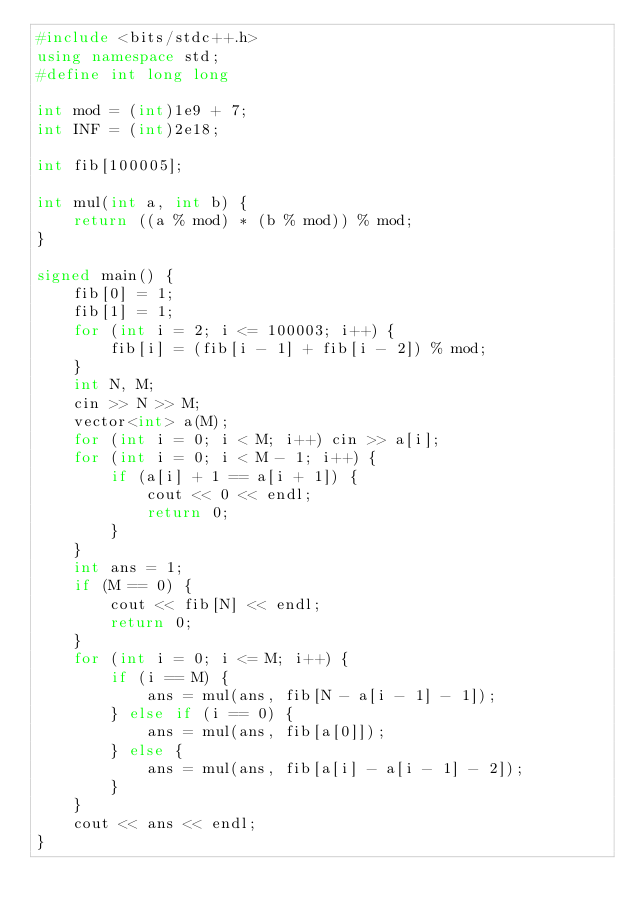<code> <loc_0><loc_0><loc_500><loc_500><_C++_>#include <bits/stdc++.h>
using namespace std;
#define int long long

int mod = (int)1e9 + 7;
int INF = (int)2e18;

int fib[100005];

int mul(int a, int b) {
    return ((a % mod) * (b % mod)) % mod;
}

signed main() {
    fib[0] = 1;
    fib[1] = 1;
    for (int i = 2; i <= 100003; i++) {
        fib[i] = (fib[i - 1] + fib[i - 2]) % mod;
    }
    int N, M;
    cin >> N >> M;
    vector<int> a(M);
    for (int i = 0; i < M; i++) cin >> a[i];
    for (int i = 0; i < M - 1; i++) {
        if (a[i] + 1 == a[i + 1]) {
            cout << 0 << endl;
            return 0;
        }
    }
    int ans = 1;
    if (M == 0) {
        cout << fib[N] << endl;
        return 0;
    }
    for (int i = 0; i <= M; i++) {
        if (i == M) {
            ans = mul(ans, fib[N - a[i - 1] - 1]);
        } else if (i == 0) {
            ans = mul(ans, fib[a[0]]);
        } else {
            ans = mul(ans, fib[a[i] - a[i - 1] - 2]);
        }
    }
    cout << ans << endl;
}
</code> 